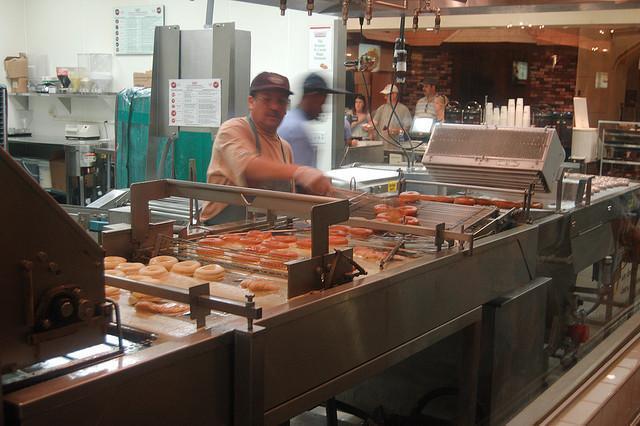What are the people in the background doing?
Select the correct answer and articulate reasoning with the following format: 'Answer: answer
Rationale: rationale.'
Options: Serving customers, buy donuts, delivering drinks, delivering donuts. Answer: buy donuts.
Rationale: The people in the background are standing on the opposite side of a counter from the visible register which is the place a customer would stand. there appears to be donuts cooking in the foreground so the people making purchases are likely buying donuts. 